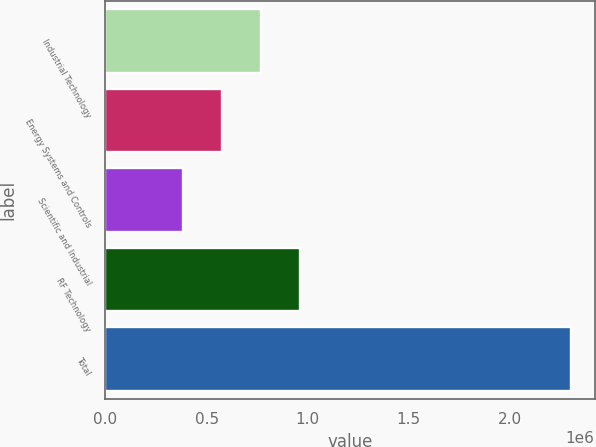Convert chart. <chart><loc_0><loc_0><loc_500><loc_500><bar_chart><fcel>Industrial Technology<fcel>Energy Systems and Controls<fcel>Scientific and Industrial<fcel>RF Technology<fcel>Total<nl><fcel>767607<fcel>575575<fcel>383543<fcel>959638<fcel>2.30386e+06<nl></chart> 